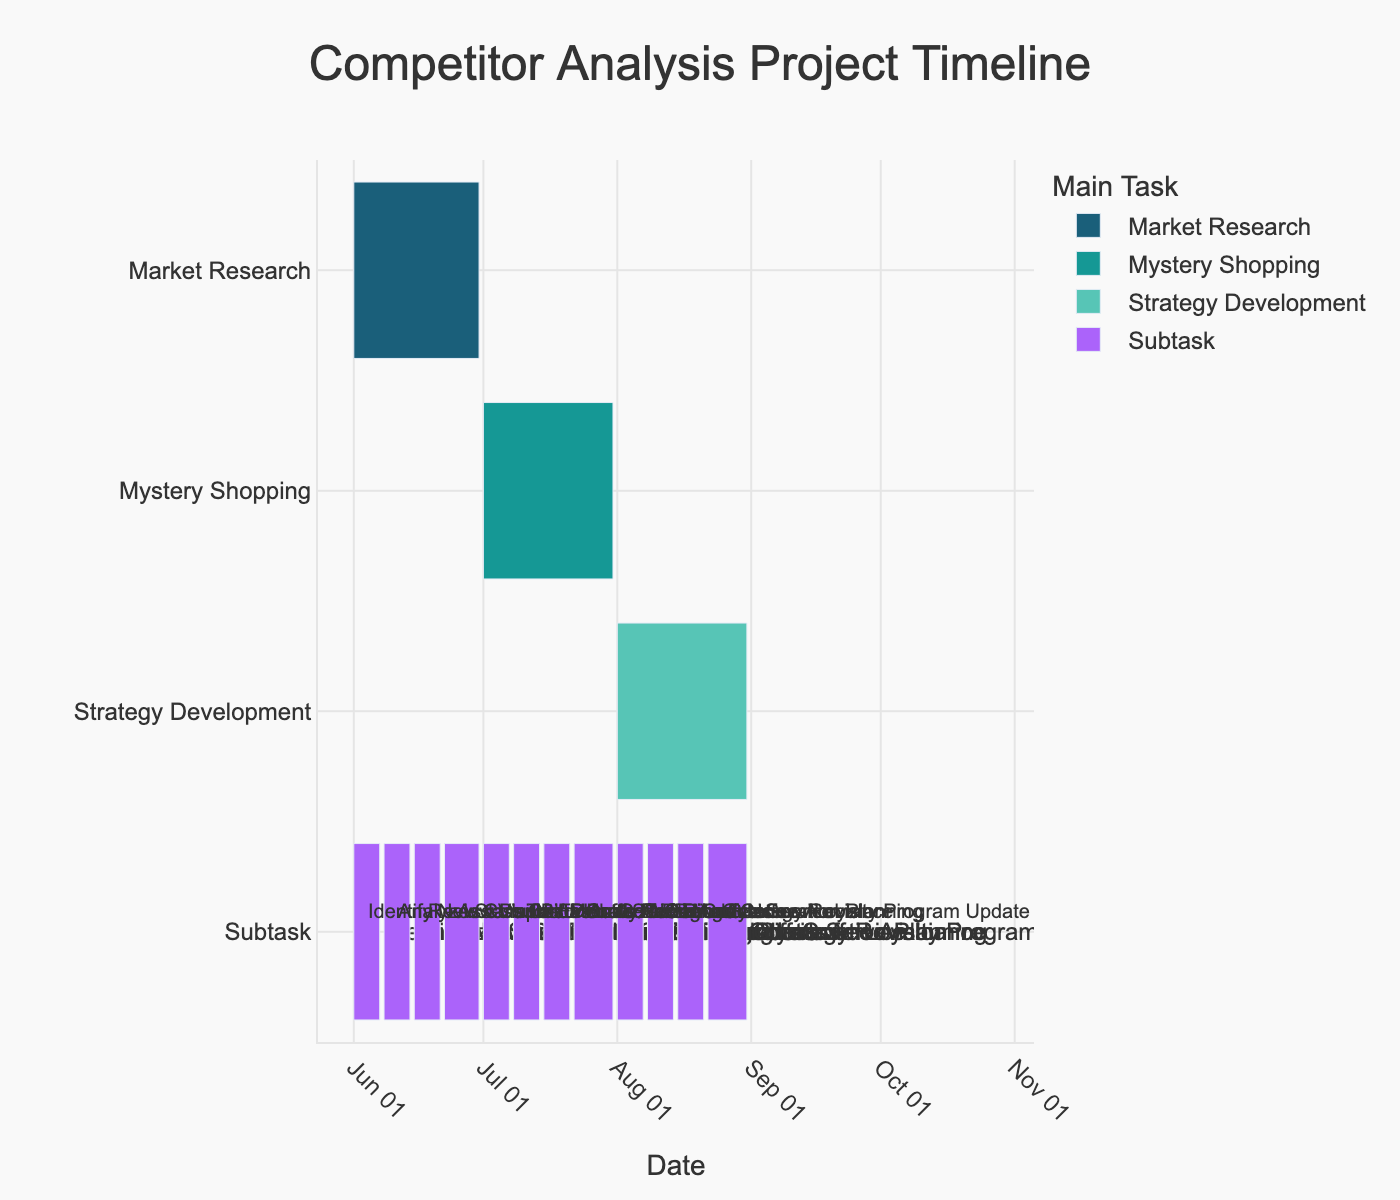What is the title of the Gantt chart? The title of the chart is typically found at the top and provides a summary of what the chart represents. Look for the large, bold text above the Gantt bars.
Answer: Competitor Analysis Project Timeline What are the three main tasks listed in the chart? Main tasks are usually highlighted and differentiated from subtasks in a Gantt chart. The bars for these tasks have unique colors and are often labeled directly.
Answer: Market Research, Mystery Shopping, Strategy Development How long is the entire Competitor Analysis Project expected to take? To determine the entire project duration, look at the start date of the first task and the end date of the last task. Subtracting the start from the end date will give the total time span.
Answer: 3 months Which main task has the largest number of subtasks? Count the number of subtasks under each main task. The main task with the most individual items listed below it has the largest number of subtasks.
Answer: Mystery Shopping Between what dates does the 'Review Dunkin' Donuts Pricing' subtask occur? Locate the 'Review Dunkin' Donuts Pricing' subtask in the Gantt chart and identify the start and end dates associated with it by checking the length and positioning of the bar.
Answer: June 15 to June 21 Which task runs concurrently with 'Identify New Competitors'? Find 'Identify New Competitors' in the chart and see if any other task has bars overlapping its start and end dates.
Answer: Market Research What is the main task color associated with 'Strategy Development'? Different main tasks in the Gantt chart are color-coded. Identify the color of the bars corresponding to 'Strategy Development'.
Answer: #57C5B6 How many days does the 'SWOT Analysis' subtask last? Calculate the difference between the start and end dates of 'SWOT Analysis'. Count all the days between these dates inclusively.
Answer: 7 days What is the shortest subtask listed under 'Strategy Development'? Determine the duration of each subtask under 'Strategy Development' by calculating the difference between their start and end dates. Compare these durations to find the shortest one.
Answer: SWOT Analysis When does the 'Customer Loyalty Program Update' subtask end? Find 'Customer Loyalty Program Update' in the subtask list under 'Strategy Development' and identify its end date from the Gantt chart.
Answer: August 31 